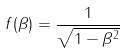Convert formula to latex. <formula><loc_0><loc_0><loc_500><loc_500>f ( \beta ) = \frac { 1 } { \sqrt { 1 - \beta ^ { 2 } } }</formula> 